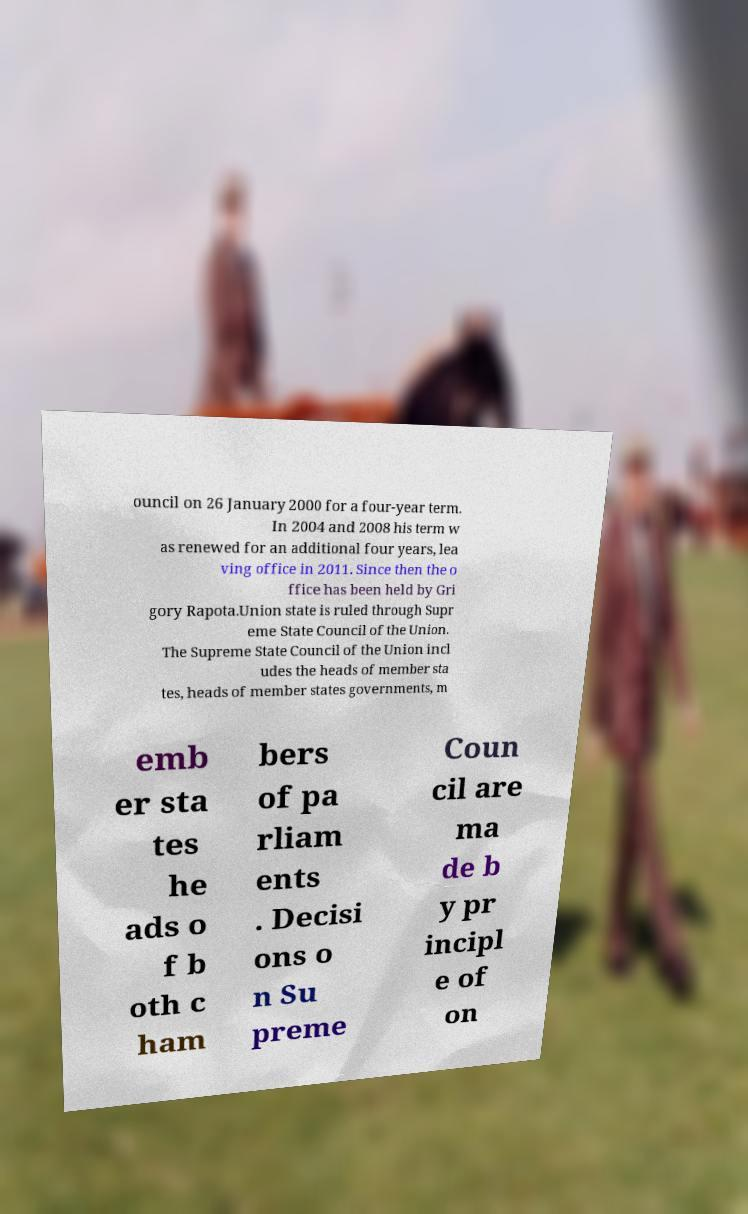For documentation purposes, I need the text within this image transcribed. Could you provide that? ouncil on 26 January 2000 for a four-year term. In 2004 and 2008 his term w as renewed for an additional four years, lea ving office in 2011. Since then the o ffice has been held by Gri gory Rapota.Union state is ruled through Supr eme State Council of the Union. The Supreme State Council of the Union incl udes the heads of member sta tes, heads of member states governments, m emb er sta tes he ads o f b oth c ham bers of pa rliam ents . Decisi ons o n Su preme Coun cil are ma de b y pr incipl e of on 